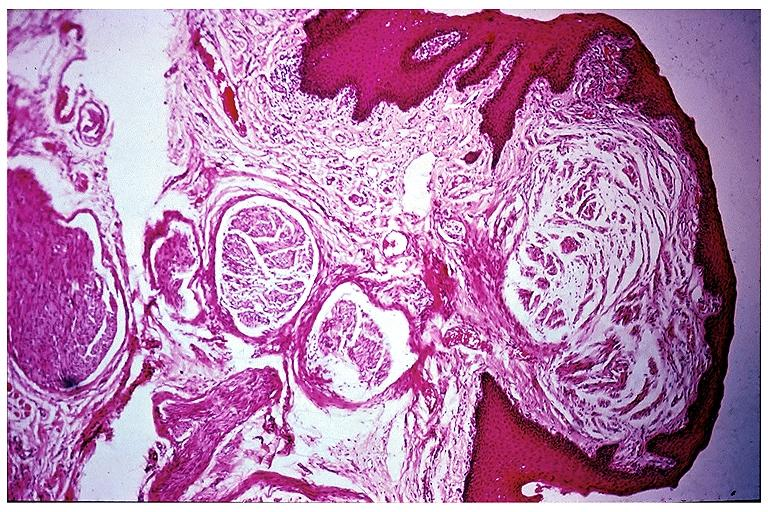what is present?
Answer the question using a single word or phrase. Oral 